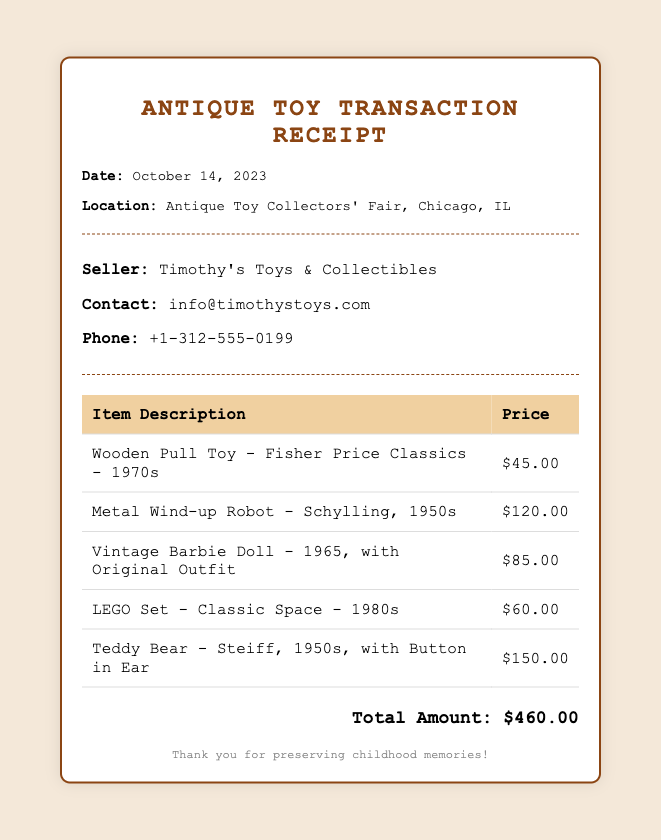what is the date of the receipt? The date of the receipt is listed in the document as October 14, 2023.
Answer: October 14, 2023 who is the seller of the antique toys? The seller's name is mentioned at the top of the seller information section as Timothy's Toys & Collectibles.
Answer: Timothy's Toys & Collectibles how much does the Vintage Barbie Doll cost? The price for the Vintage Barbie Doll is specified in the item table.
Answer: $85.00 what item was purchased from the 1950s that costs the most? The table lists a Teddy Bear from the 1950s with the highest price among the items.
Answer: Teddy Bear - Steiff, 1950s, with Button in Ear what is the total amount spent on all items? The total amount is summarized at the bottom of the receipt after listing all item prices.
Answer: $460.00 what is the contact email for the seller? The seller's contact information includes an email address listed in the seller information section.
Answer: info@timothystoys.com how many items are listed on the receipt? The number of items can be counted from the rows of the table provided in the document.
Answer: 5 which item is categorized as a "Pull Toy"? The specific categorization of the Wooden Pull Toy is mentioned clearly in the item description.
Answer: Wooden Pull Toy - Fisher Price Classics - 1970s 